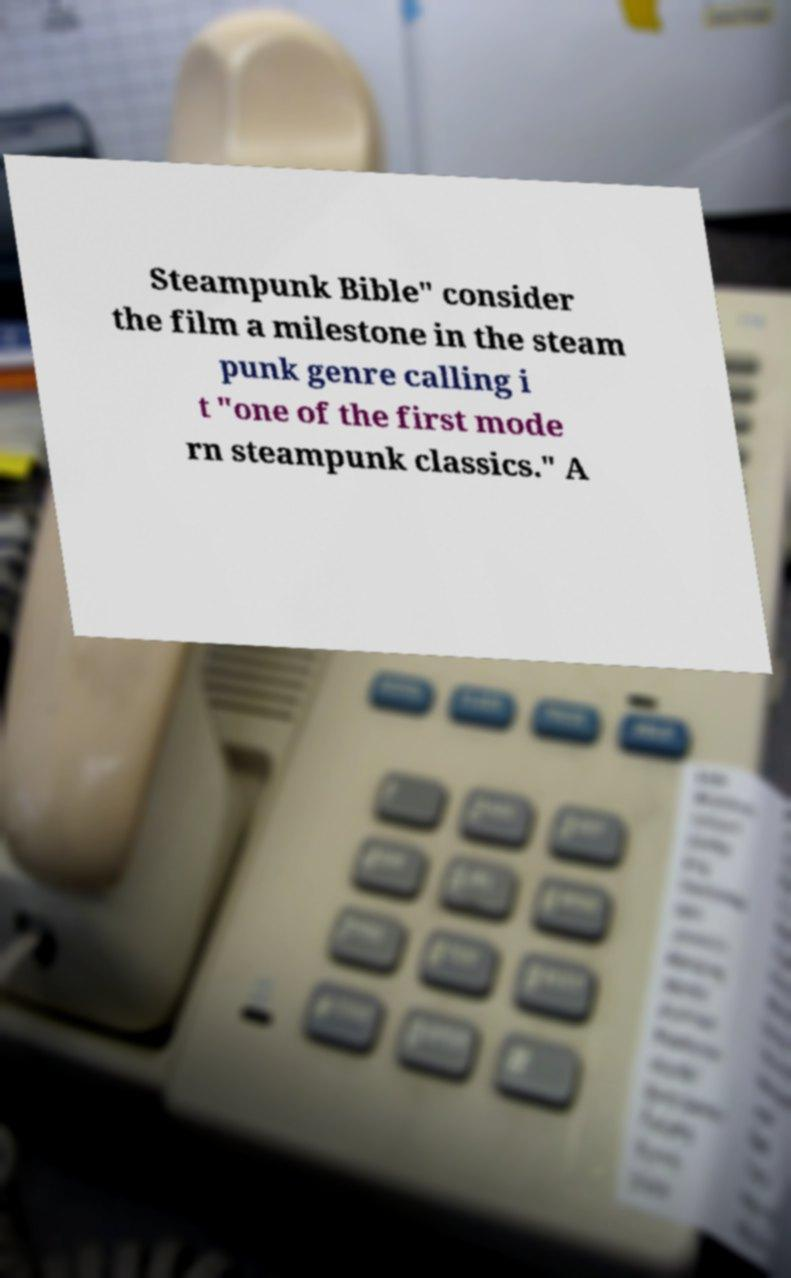I need the written content from this picture converted into text. Can you do that? Steampunk Bible" consider the film a milestone in the steam punk genre calling i t "one of the first mode rn steampunk classics." A 